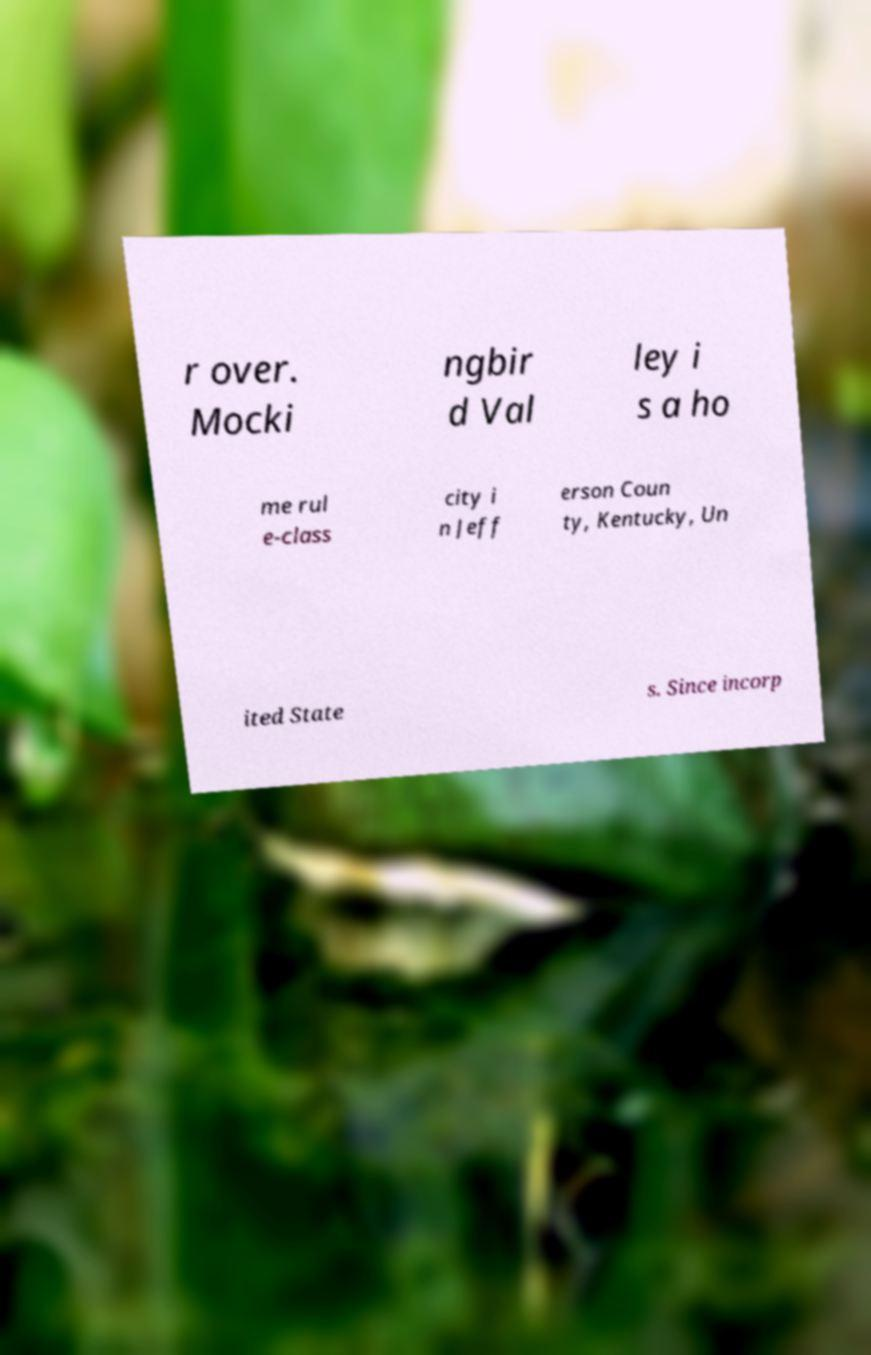Please read and relay the text visible in this image. What does it say? r over. Mocki ngbir d Val ley i s a ho me rul e-class city i n Jeff erson Coun ty, Kentucky, Un ited State s. Since incorp 